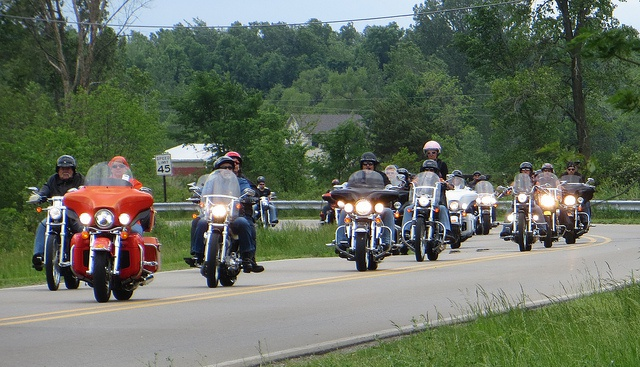Describe the objects in this image and their specific colors. I can see motorcycle in gray, black, maroon, brown, and darkgray tones, motorcycle in gray, black, white, and darkgray tones, motorcycle in gray, black, darkgray, and white tones, motorcycle in gray, black, darkgray, and white tones, and motorcycle in gray, black, ivory, and navy tones in this image. 